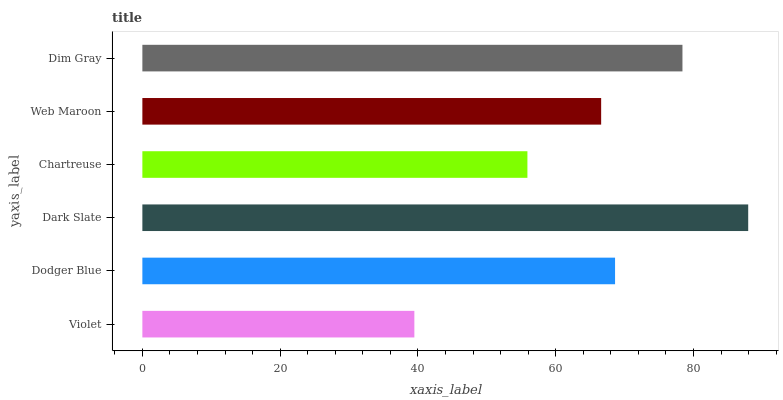Is Violet the minimum?
Answer yes or no. Yes. Is Dark Slate the maximum?
Answer yes or no. Yes. Is Dodger Blue the minimum?
Answer yes or no. No. Is Dodger Blue the maximum?
Answer yes or no. No. Is Dodger Blue greater than Violet?
Answer yes or no. Yes. Is Violet less than Dodger Blue?
Answer yes or no. Yes. Is Violet greater than Dodger Blue?
Answer yes or no. No. Is Dodger Blue less than Violet?
Answer yes or no. No. Is Dodger Blue the high median?
Answer yes or no. Yes. Is Web Maroon the low median?
Answer yes or no. Yes. Is Chartreuse the high median?
Answer yes or no. No. Is Dim Gray the low median?
Answer yes or no. No. 